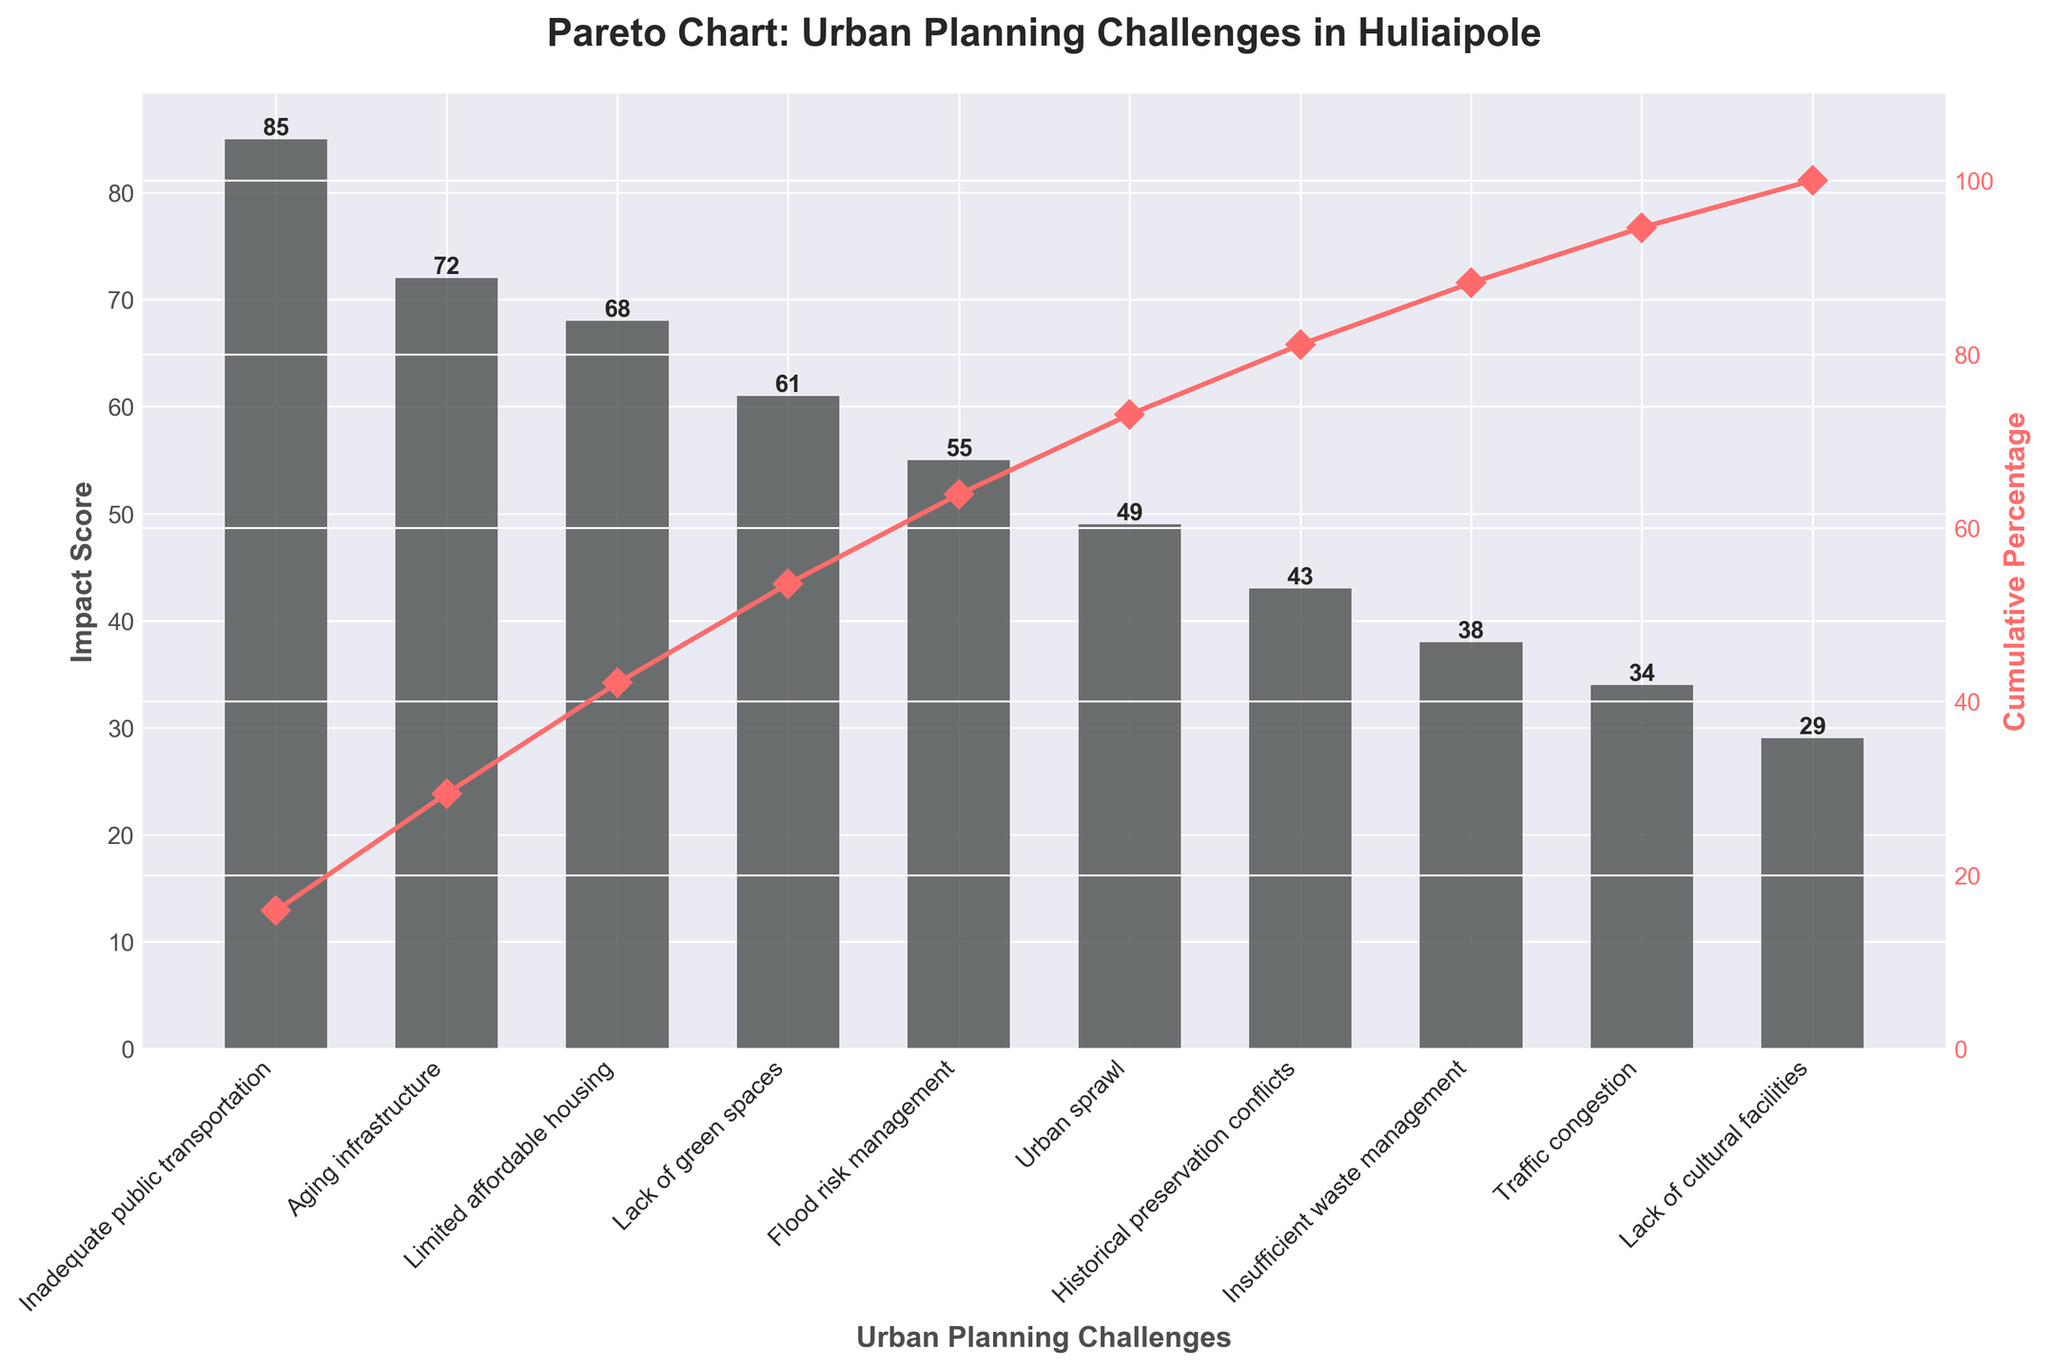what is the title of the chart? The title is visible at the top of the Pareto chart.
Answer: Pareto Chart: Urban Planning Challenges in Huliaipole Which challenge has the highest impact score? The challenge with the highest impact score is the tallest bar in the chart.
Answer: Inadequate public transportation What cumulative percentage is achieved after including the top three challenges? The cumulative percentage is indicated by the line graph. By adding the top three challenges, it reaches 68 + 85 + 72 = 225; cumulative percentage is derived from plotting this value, but visually it is approximately 73%.
Answer: ~73% How does the impact score of Lack of cultural facilities compare to Traffic congestion? Compare the heights of the bars for both categories in the chart.
Answer: Lack of cultural facilities has a lower impact score Calculate the total impact score of the challenges related to infrastructure. The related categories are 'Aging infrastructure' (72) and 'Insufficient waste management' (38). Add these scores together: 72 + 38 = 110.
Answer: 110 What is the cumulative percentage of the top five challenges together? Add the impact scores of the top five challenges and then calculate the cumulative percentage over the total sum. 85 + 72 + 68 + 61 + 55 = 341. Find its percentage out of total impact scores. (341 / Sum of all impact scores) * 100
Answer: ~82.6% What challenge has a higher impact score, Aging infrastructure or Urban sprawl? Compare the height of the bars for both challenges.
Answer: Aging infrastructure What are the first three challenges when listed by impact score? Look at the top three tallest bars on the chart in descending order.
Answer: Inadequate public transportation, Aging infrastructure, Limited affordable housing By how many points does the impact score of inadequate public transportation exceed historical preservation conflicts? Subtract the impact score of Historical preservation conflicts from that of Inadequate public transportation (85 - 43).
Answer: 42 What is the cumulative percentage after including challenges scoring less than 50? Add the impact scores of challenges with scores less than 50, then calculate their cumulative percentage. Urban sprawl + Historical preservation conflicts + Insufficient waste management + Traffic congestion + Lack of cultural facilities = 49 + 43 + 38 + 34 + 29 = 193. Compute cumulative percentage of 193 out of the total impact:  (193/485)*100
Answer: ~39.8% 